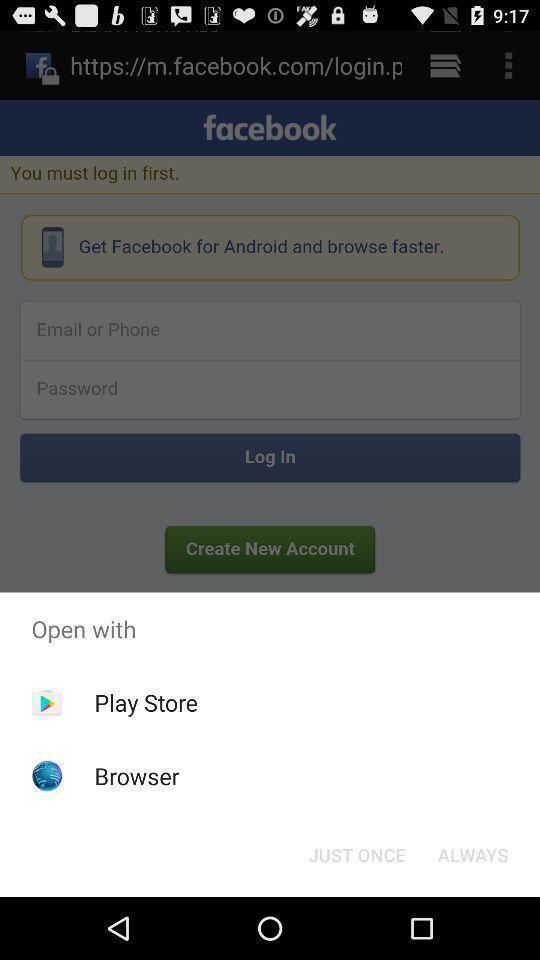Provide a textual representation of this image. Push up displaying to open the page. 